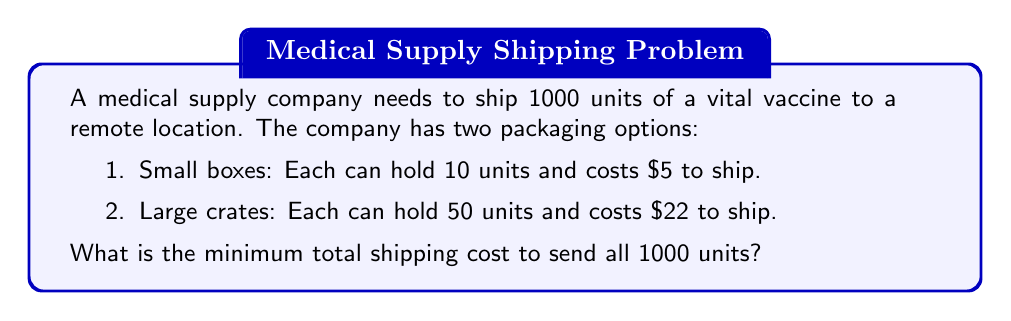Solve this math problem. Let's approach this step-by-step:

1) First, let's calculate the cost per unit for each option:

   Small boxes: $\frac{$5}{10 \text{ units}} = $0.50$ per unit
   Large crates: $\frac{$22}{50 \text{ units}} = $0.44$ per unit

2) Since the large crates have a lower cost per unit, we should use as many large crates as possible.

3) Calculate how many large crates we need:
   $\left\lfloor\frac{1000 \text{ units}}{50 \text{ units/crate}}\right\rfloor = 20$ crates

4) Calculate how many units are left after using large crates:
   $1000 - (20 \times 50) = 0$ units

5) Calculate the total cost for large crates:
   $20 \times $22 = $440$

6) Since there are no units left, we don't need any small boxes.

7) The total minimum shipping cost is therefore $440.
Answer: $440 